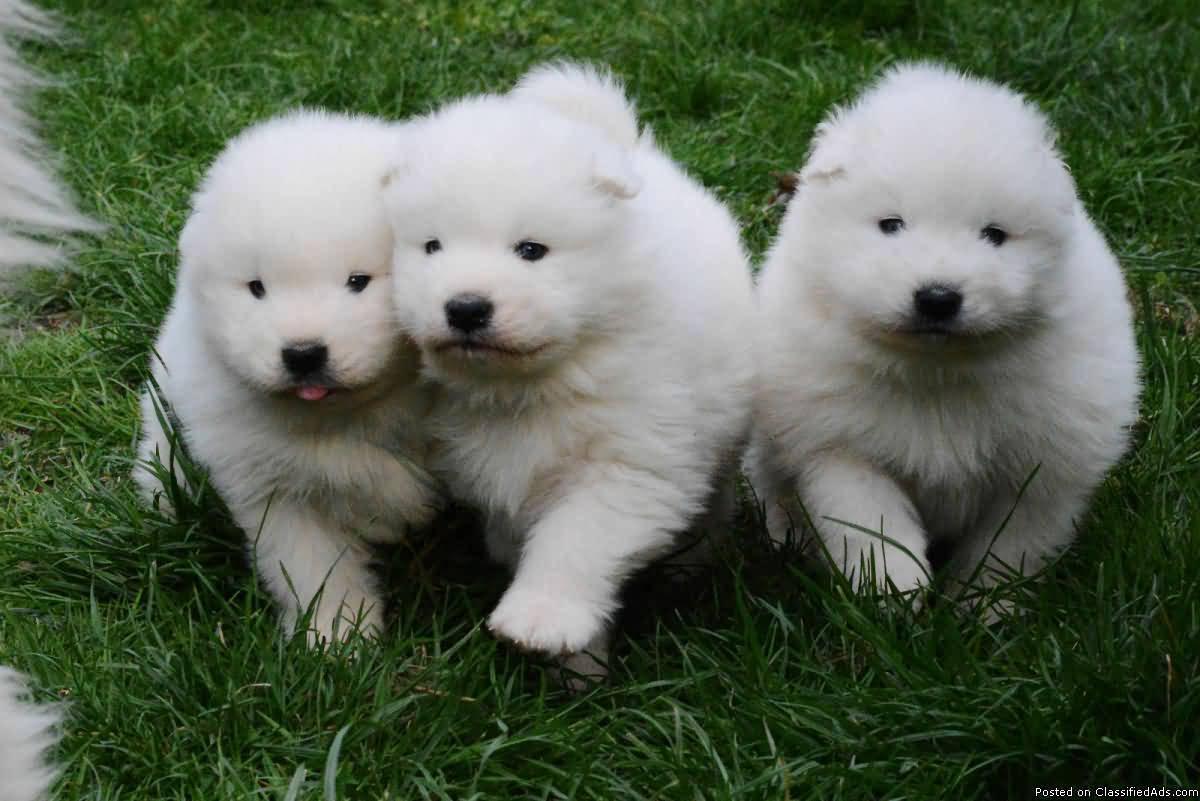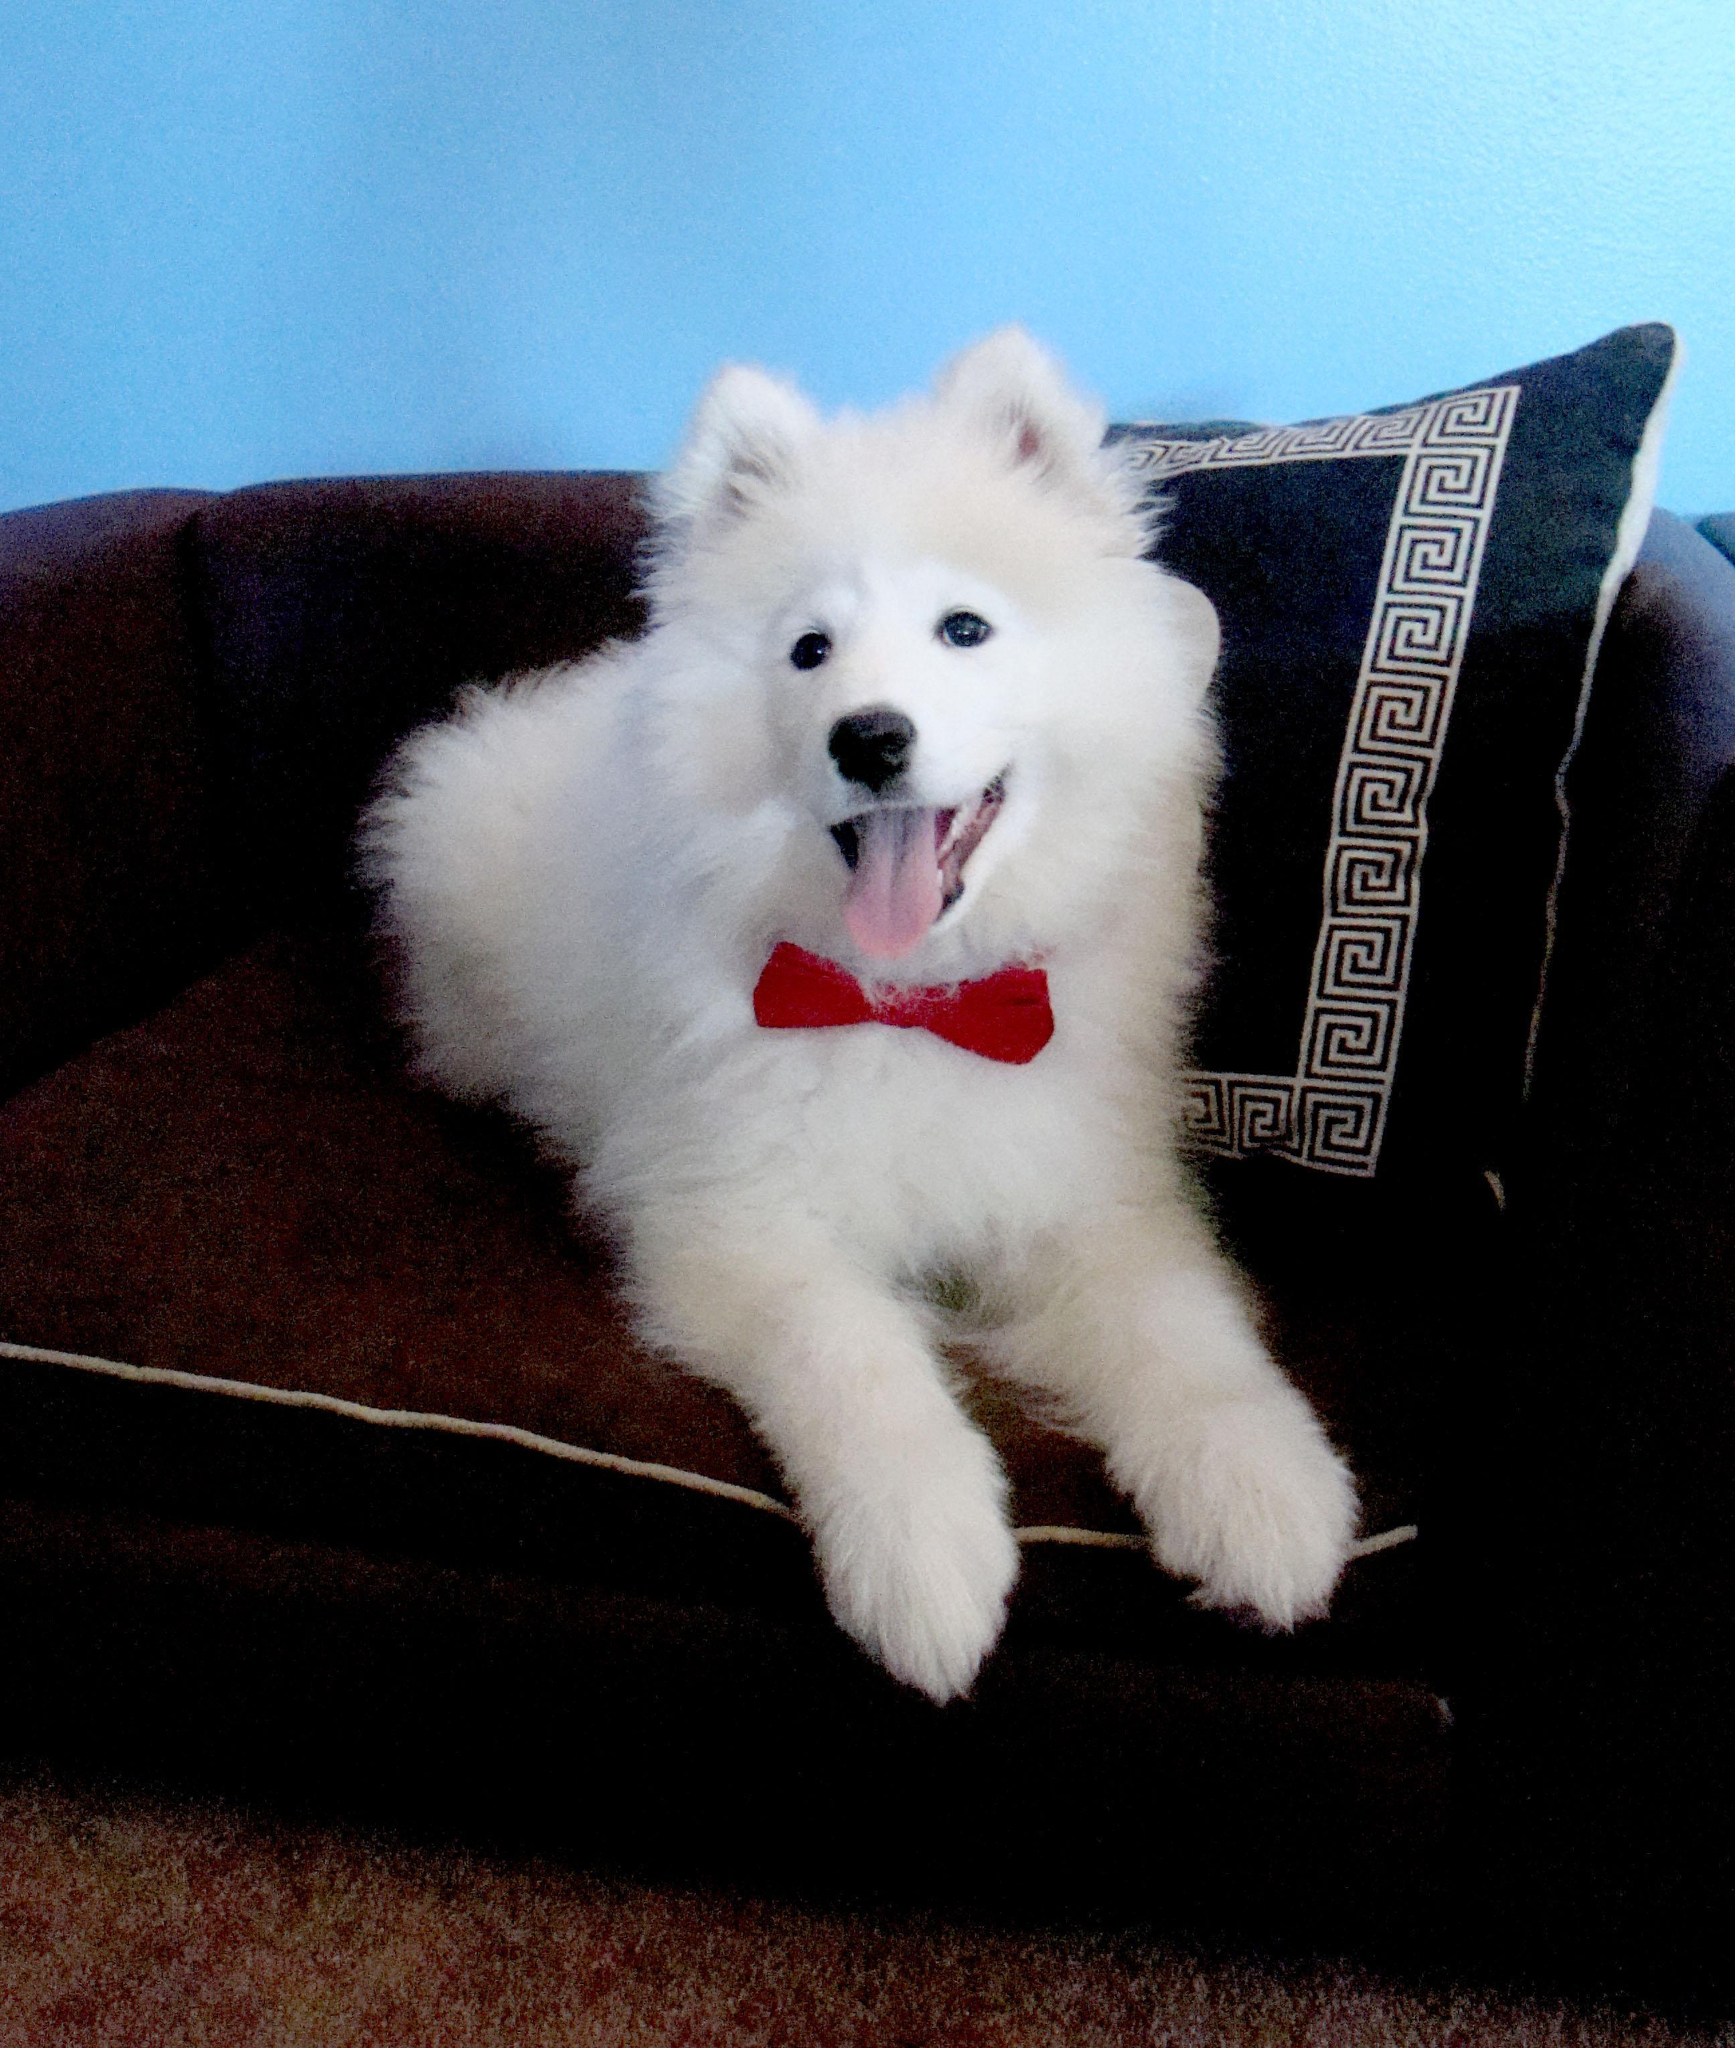The first image is the image on the left, the second image is the image on the right. For the images shown, is this caption "The left image shows a woman next to no less than one white dog" true? Answer yes or no. No. The first image is the image on the left, the second image is the image on the right. For the images displayed, is the sentence "An image shows a trio of side-by-side white puppies on green grass, facing forward with not all paws on the ground." factually correct? Answer yes or no. Yes. 